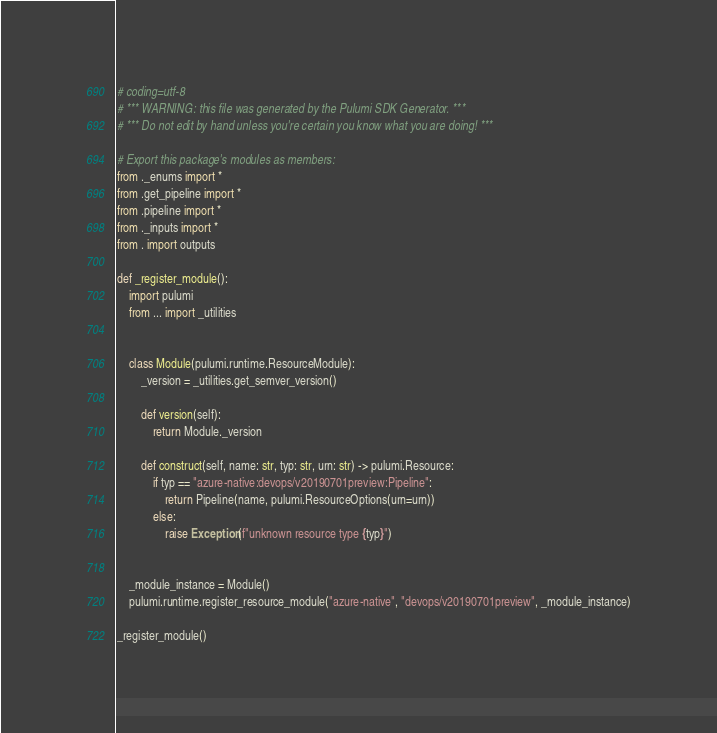Convert code to text. <code><loc_0><loc_0><loc_500><loc_500><_Python_># coding=utf-8
# *** WARNING: this file was generated by the Pulumi SDK Generator. ***
# *** Do not edit by hand unless you're certain you know what you are doing! ***

# Export this package's modules as members:
from ._enums import *
from .get_pipeline import *
from .pipeline import *
from ._inputs import *
from . import outputs

def _register_module():
    import pulumi
    from ... import _utilities


    class Module(pulumi.runtime.ResourceModule):
        _version = _utilities.get_semver_version()

        def version(self):
            return Module._version

        def construct(self, name: str, typ: str, urn: str) -> pulumi.Resource:
            if typ == "azure-native:devops/v20190701preview:Pipeline":
                return Pipeline(name, pulumi.ResourceOptions(urn=urn))
            else:
                raise Exception(f"unknown resource type {typ}")


    _module_instance = Module()
    pulumi.runtime.register_resource_module("azure-native", "devops/v20190701preview", _module_instance)

_register_module()
</code> 